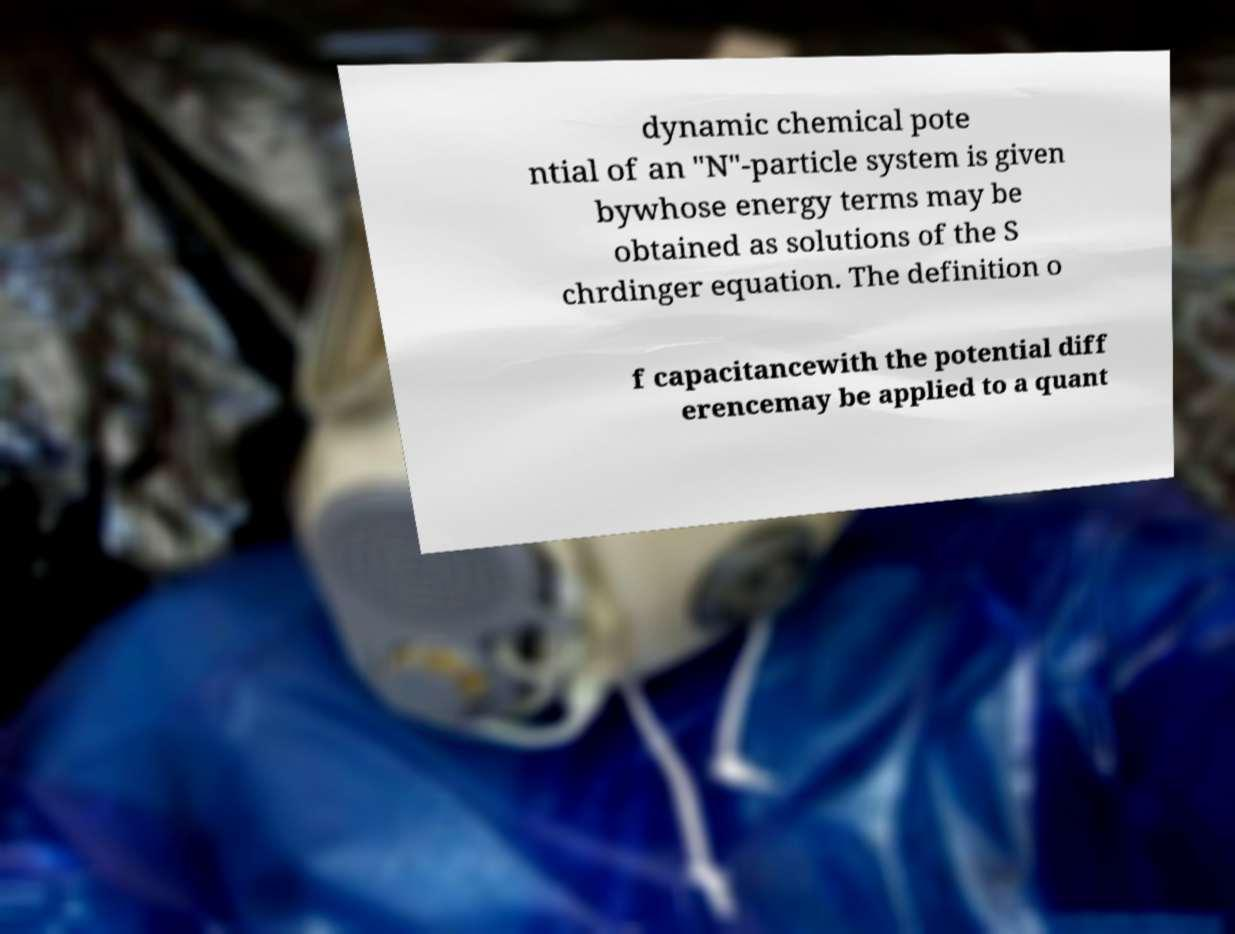What messages or text are displayed in this image? I need them in a readable, typed format. dynamic chemical pote ntial of an "N"-particle system is given bywhose energy terms may be obtained as solutions of the S chrdinger equation. The definition o f capacitancewith the potential diff erencemay be applied to a quant 